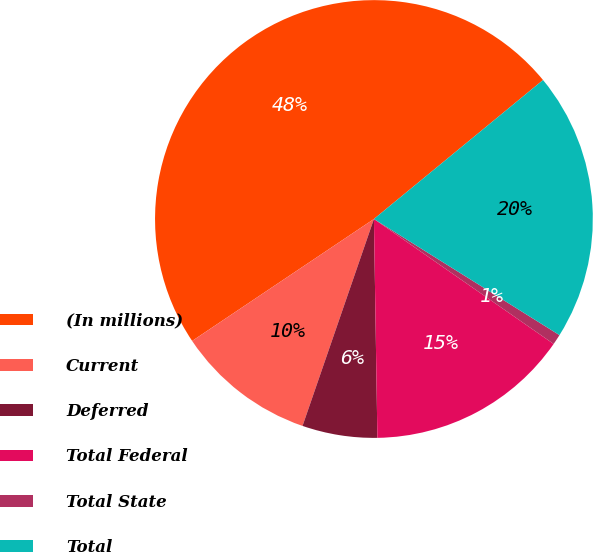<chart> <loc_0><loc_0><loc_500><loc_500><pie_chart><fcel>(In millions)<fcel>Current<fcel>Deferred<fcel>Total Federal<fcel>Total State<fcel>Total<nl><fcel>48.46%<fcel>10.31%<fcel>5.54%<fcel>15.08%<fcel>0.77%<fcel>19.85%<nl></chart> 